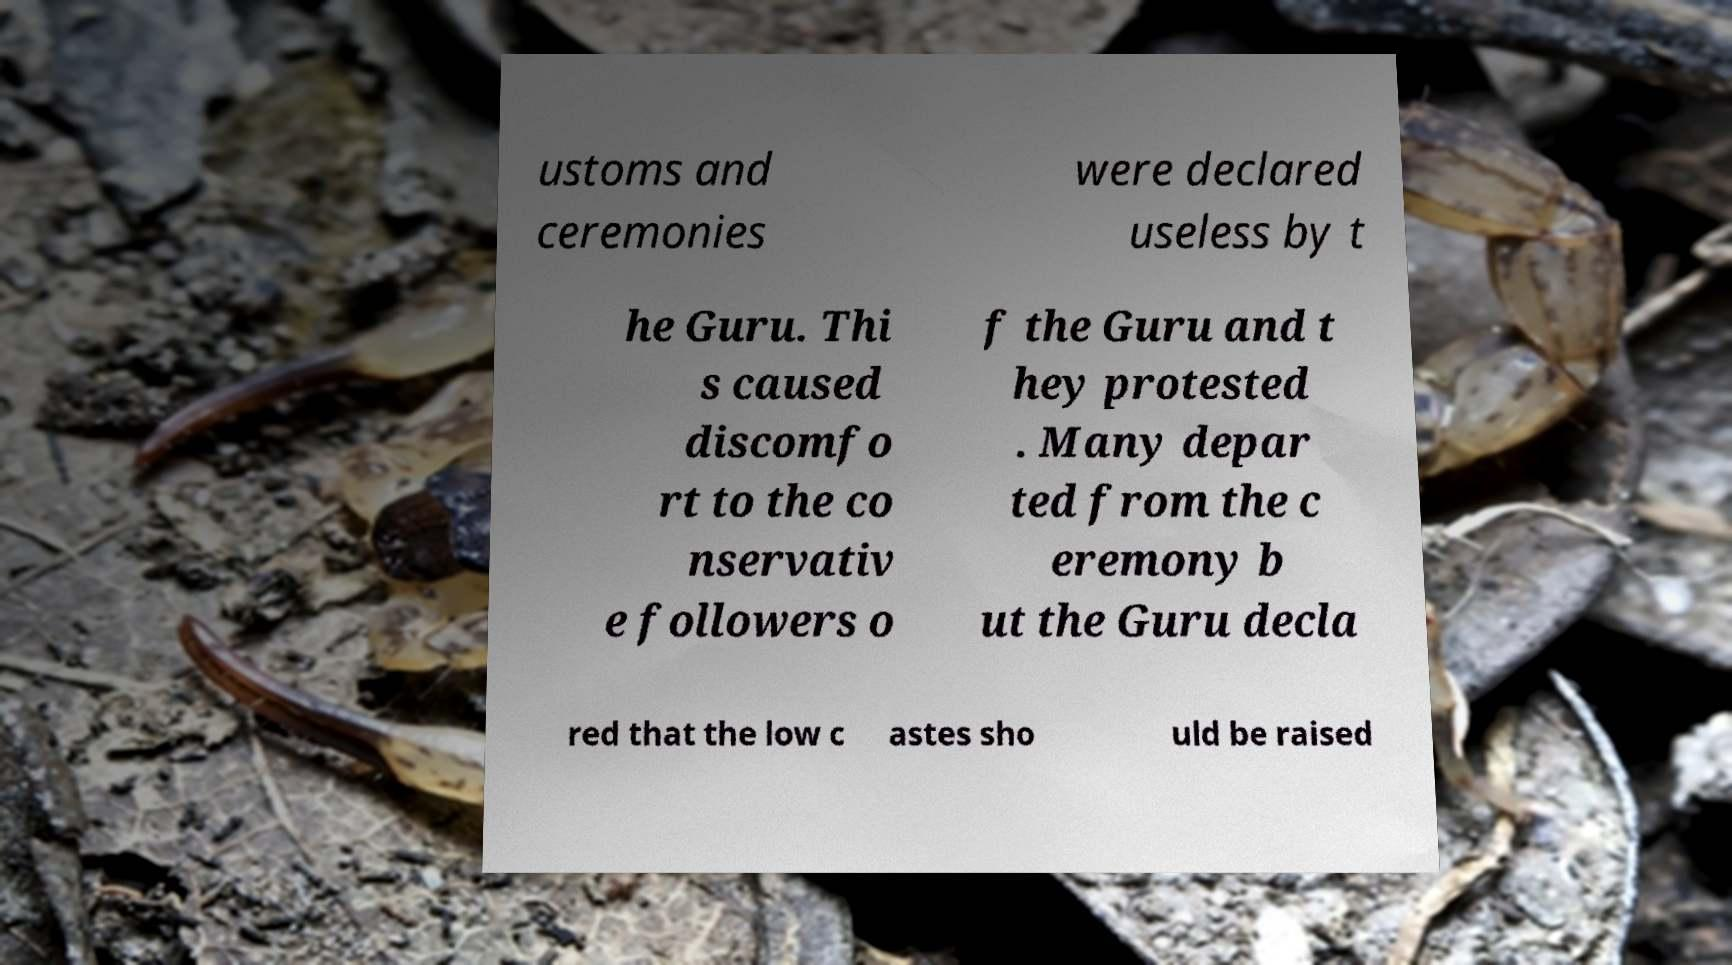Please identify and transcribe the text found in this image. ustoms and ceremonies were declared useless by t he Guru. Thi s caused discomfo rt to the co nservativ e followers o f the Guru and t hey protested . Many depar ted from the c eremony b ut the Guru decla red that the low c astes sho uld be raised 